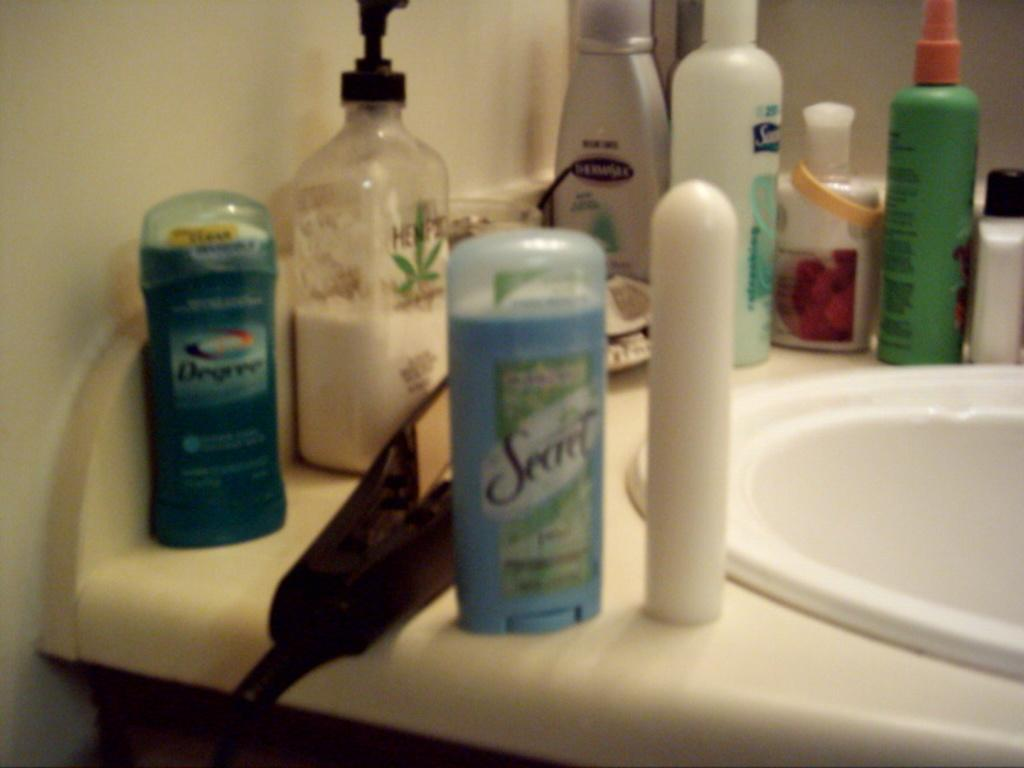<image>
Relay a brief, clear account of the picture shown. Bathroom with a blue Secret deoderant bottle on the sink. 